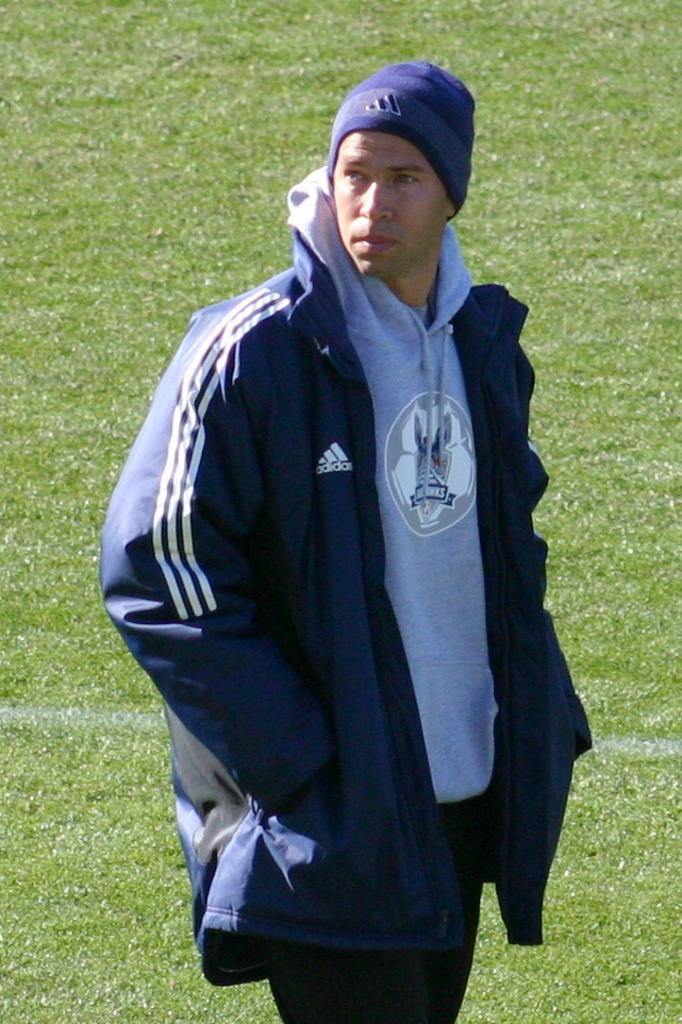Who is present in the image? There is a man in the image. What is the man wearing on his upper body? The man is wearing a blue jacket. What type of headwear is the man wearing? The man is wearing a cap. What type of terrain is visible in the image? There is grass visible in the image. What is the weather like in the image? It is a sunny day. What type of parenting advice can be seen in the image? There is no parenting advice present in the image; it features a man wearing a blue jacket and cap, with grass visible in the background on a sunny day. 